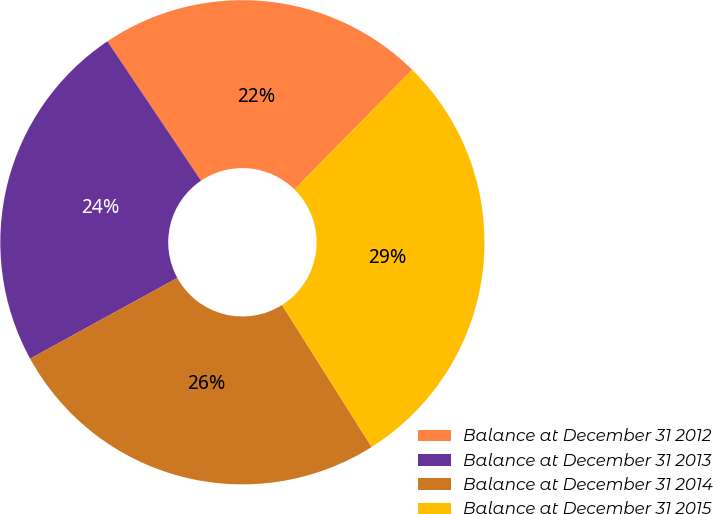<chart> <loc_0><loc_0><loc_500><loc_500><pie_chart><fcel>Balance at December 31 2012<fcel>Balance at December 31 2013<fcel>Balance at December 31 2014<fcel>Balance at December 31 2015<nl><fcel>21.79%<fcel>23.57%<fcel>25.98%<fcel>28.66%<nl></chart> 